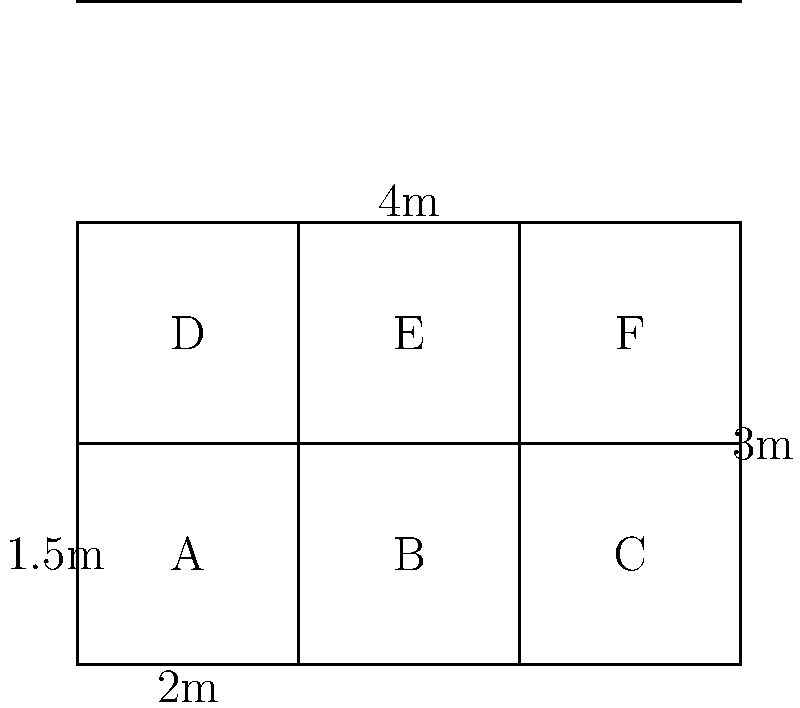A new recycling center is being planned for the city. The layout includes a grid of rectangular recycling bins as shown in the diagram. Each bin has a width of 2 meters and a length of 1.5 meters. If there are 6 bins arranged in a 3x2 grid, what is the total area covered by all the recycling bins? To find the total area covered by all the recycling bins, we'll follow these steps:

1. Calculate the area of a single bin:
   Area of one bin = Width × Length
   $A_{bin} = 2\text{ m} \times 1.5\text{ m} = 3\text{ m}^2$

2. Count the total number of bins:
   There are 6 bins in total (A, B, C, D, E, and F)

3. Calculate the total area by multiplying the area of one bin by the number of bins:
   Total Area = Area of one bin × Number of bins
   $A_{total} = 3\text{ m}^2 \times 6 = 18\text{ m}^2$

Therefore, the total area covered by all the recycling bins is 18 square meters.
Answer: $18\text{ m}^2$ 